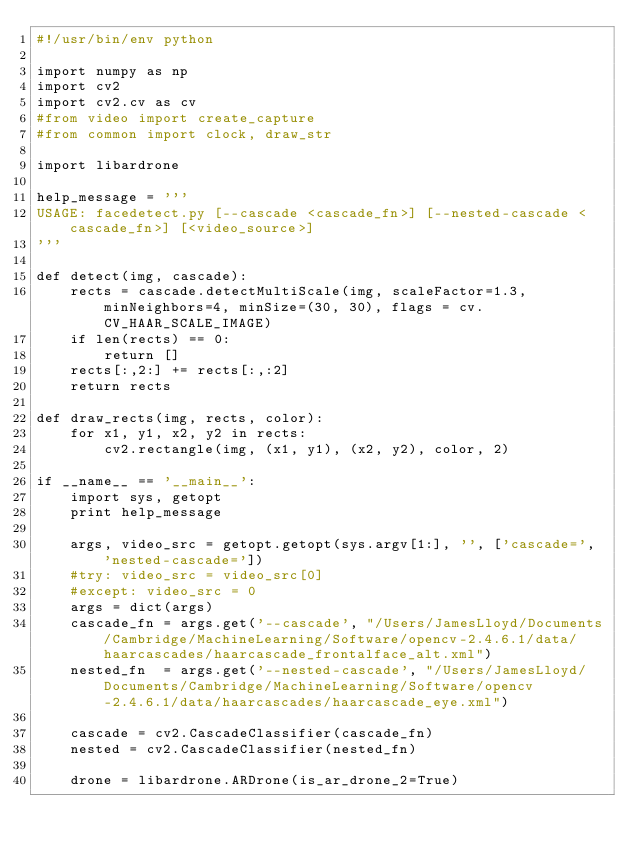Convert code to text. <code><loc_0><loc_0><loc_500><loc_500><_Python_>#!/usr/bin/env python

import numpy as np
import cv2
import cv2.cv as cv
#from video import create_capture
#from common import clock, draw_str

import libardrone

help_message = '''
USAGE: facedetect.py [--cascade <cascade_fn>] [--nested-cascade <cascade_fn>] [<video_source>]
'''

def detect(img, cascade):
    rects = cascade.detectMultiScale(img, scaleFactor=1.3, minNeighbors=4, minSize=(30, 30), flags = cv.CV_HAAR_SCALE_IMAGE)
    if len(rects) == 0:
        return []
    rects[:,2:] += rects[:,:2]
    return rects

def draw_rects(img, rects, color):
    for x1, y1, x2, y2 in rects:
        cv2.rectangle(img, (x1, y1), (x2, y2), color, 2)

if __name__ == '__main__':
    import sys, getopt
    print help_message

    args, video_src = getopt.getopt(sys.argv[1:], '', ['cascade=', 'nested-cascade='])
    #try: video_src = video_src[0]
    #except: video_src = 0
    args = dict(args)
    cascade_fn = args.get('--cascade', "/Users/JamesLloyd/Documents/Cambridge/MachineLearning/Software/opencv-2.4.6.1/data/haarcascades/haarcascade_frontalface_alt.xml")
    nested_fn  = args.get('--nested-cascade', "/Users/JamesLloyd/Documents/Cambridge/MachineLearning/Software/opencv-2.4.6.1/data/haarcascades/haarcascade_eye.xml")

    cascade = cv2.CascadeClassifier(cascade_fn)
    nested = cv2.CascadeClassifier(nested_fn)

    drone = libardrone.ARDrone(is_ar_drone_2=True)
</code> 